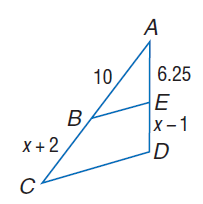Answer the mathemtical geometry problem and directly provide the correct option letter.
Question: Each pair of polygons is similar. Find B C.
Choices: A: 6.25 B: 8 C: 10 D: 12 B 